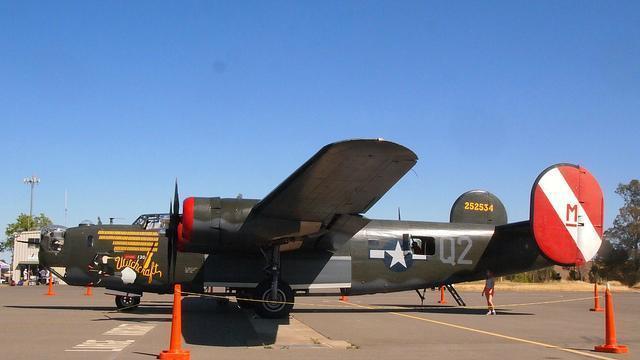How many orange cones can be seen?
Give a very brief answer. 7. 